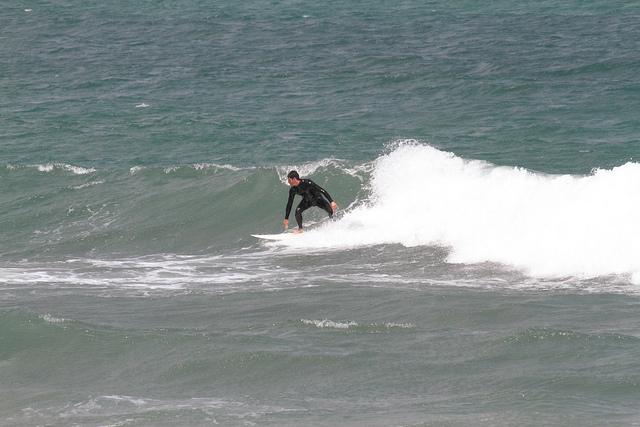What color is his suit?
Quick response, please. Black. What is he using his body weight to do?
Short answer required. Surf. What is the person wearing?
Be succinct. Wetsuit. 